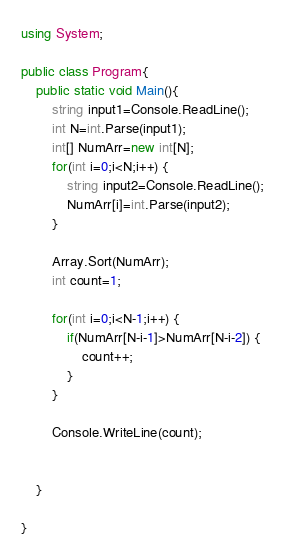Convert code to text. <code><loc_0><loc_0><loc_500><loc_500><_C#_>using System;

public class Program{
    public static void Main(){
        string input1=Console.ReadLine();
        int N=int.Parse(input1);
        int[] NumArr=new int[N];
        for(int i=0;i<N;i++) {
            string input2=Console.ReadLine();
            NumArr[i]=int.Parse(input2);
        }
        
        Array.Sort(NumArr);
        int count=1;

        for(int i=0;i<N-1;i++) {
            if(NumArr[N-i-1]>NumArr[N-i-2]) {
                count++;
            }
        }
        
        Console.WriteLine(count);


    }
    
}
</code> 